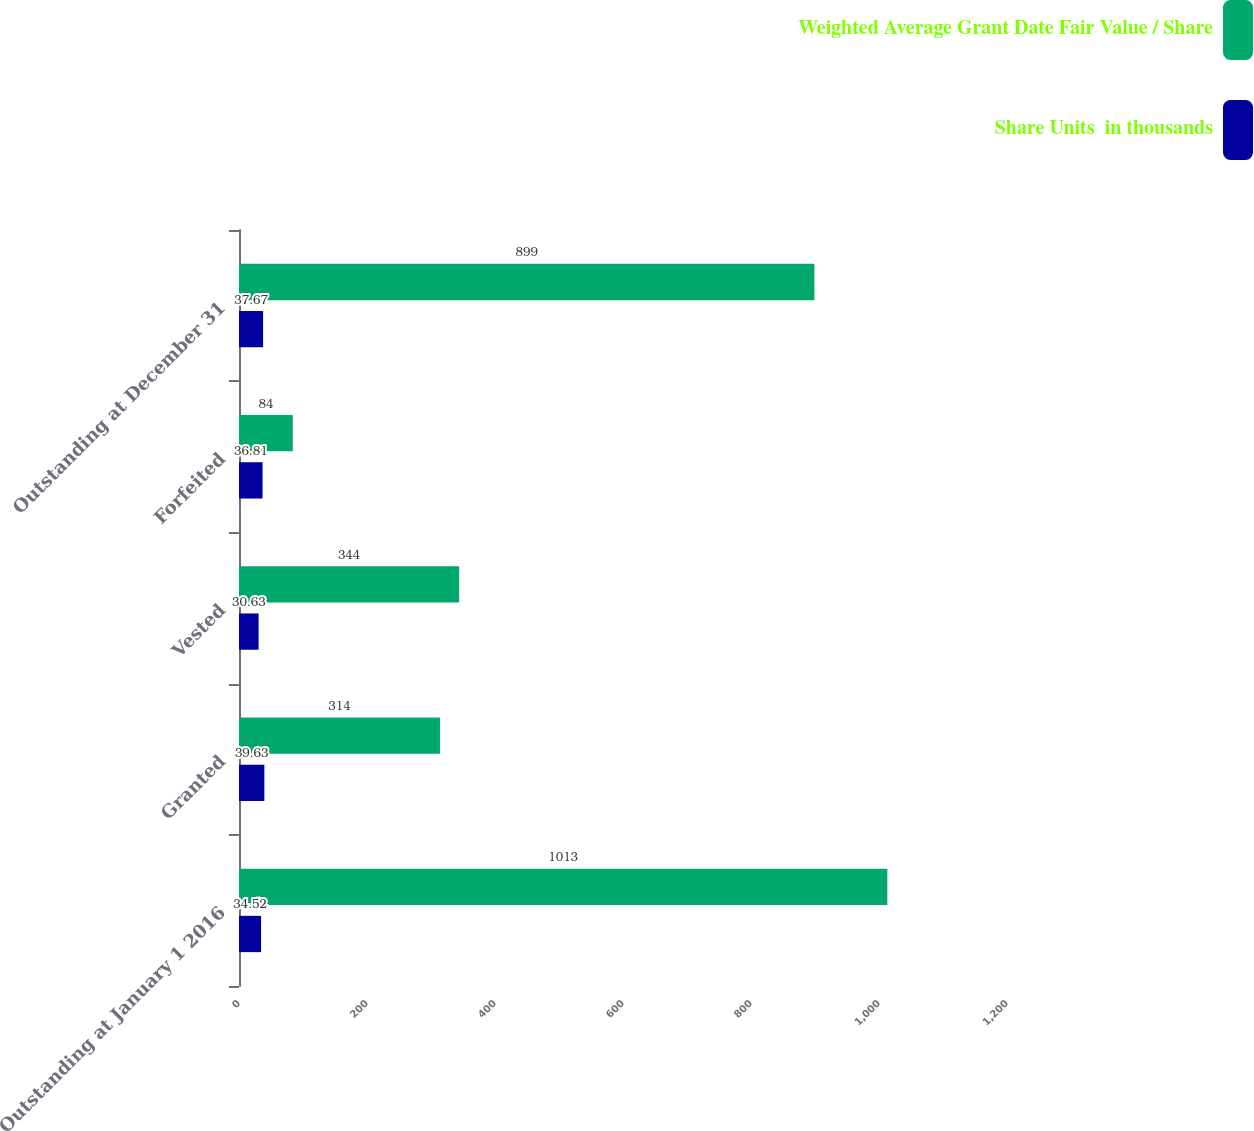Convert chart to OTSL. <chart><loc_0><loc_0><loc_500><loc_500><stacked_bar_chart><ecel><fcel>Outstanding at January 1 2016<fcel>Granted<fcel>Vested<fcel>Forfeited<fcel>Outstanding at December 31<nl><fcel>Weighted Average Grant Date Fair Value / Share<fcel>1013<fcel>314<fcel>344<fcel>84<fcel>899<nl><fcel>Share Units  in thousands<fcel>34.52<fcel>39.63<fcel>30.63<fcel>36.81<fcel>37.67<nl></chart> 